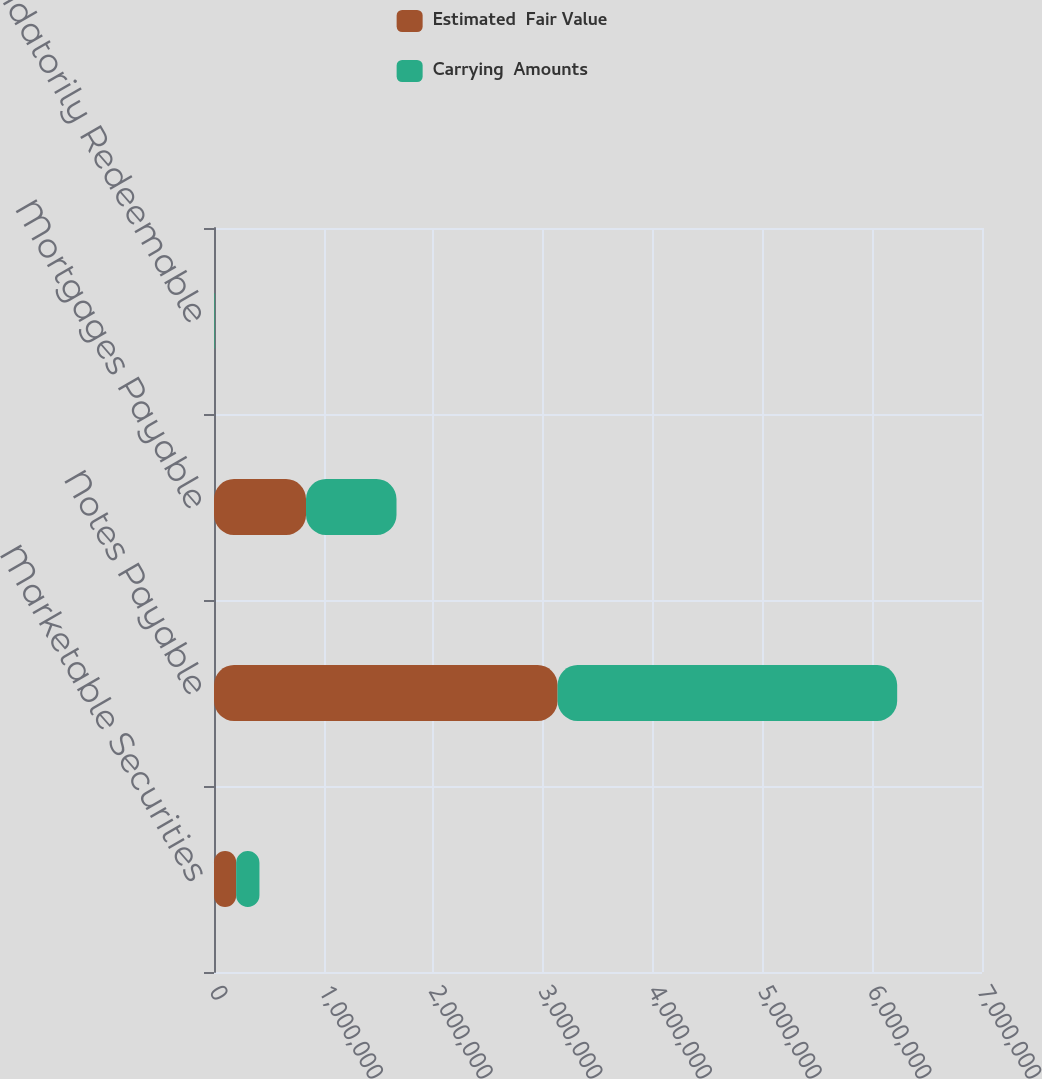<chart> <loc_0><loc_0><loc_500><loc_500><stacked_bar_chart><ecel><fcel>Marketable Securities<fcel>Notes Payable<fcel>Mortgages Payable<fcel>Mandatorily Redeemable<nl><fcel>Estimated  Fair Value<fcel>201848<fcel>3.13176e+06<fcel>838738<fcel>3070<nl><fcel>Carrying  Amounts<fcel>212451<fcel>3.095e+06<fcel>824609<fcel>6521<nl></chart> 